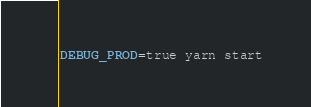<code> <loc_0><loc_0><loc_500><loc_500><_Bash_>DEBUG_PROD=true yarn start
</code> 